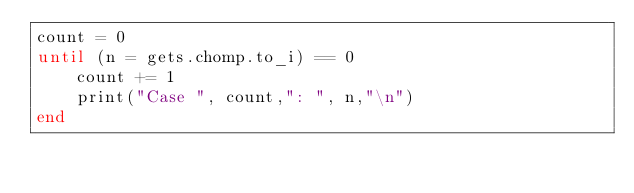<code> <loc_0><loc_0><loc_500><loc_500><_Ruby_>count = 0
until (n = gets.chomp.to_i) == 0
	count += 1
	print("Case ", count,": ", n,"\n")
end</code> 